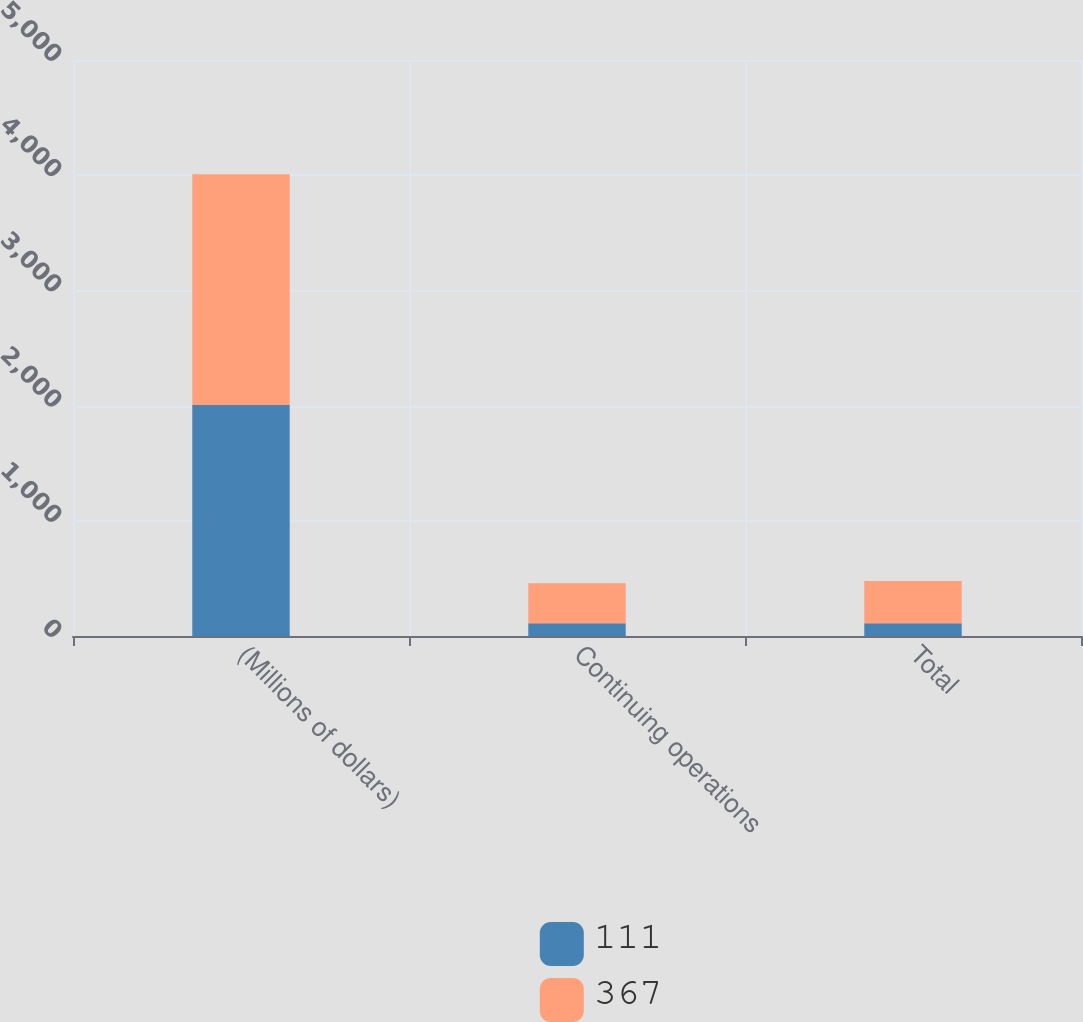<chart> <loc_0><loc_0><loc_500><loc_500><stacked_bar_chart><ecel><fcel>(Millions of dollars)<fcel>Continuing operations<fcel>Total<nl><fcel>111<fcel>2005<fcel>111<fcel>111<nl><fcel>367<fcel>2003<fcel>346<fcel>367<nl></chart> 